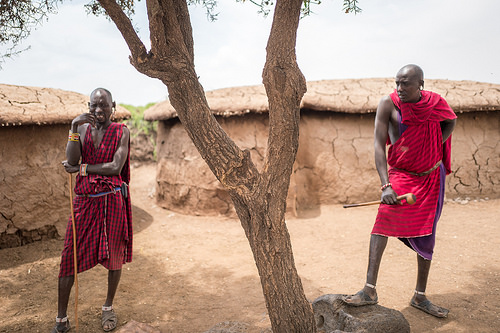<image>
Can you confirm if the man is behind the tree? Yes. From this viewpoint, the man is positioned behind the tree, with the tree partially or fully occluding the man. Where is the man in relation to the tree? Is it behind the tree? Yes. From this viewpoint, the man is positioned behind the tree, with the tree partially or fully occluding the man. Is the man next to the tree? Yes. The man is positioned adjacent to the tree, located nearby in the same general area. 